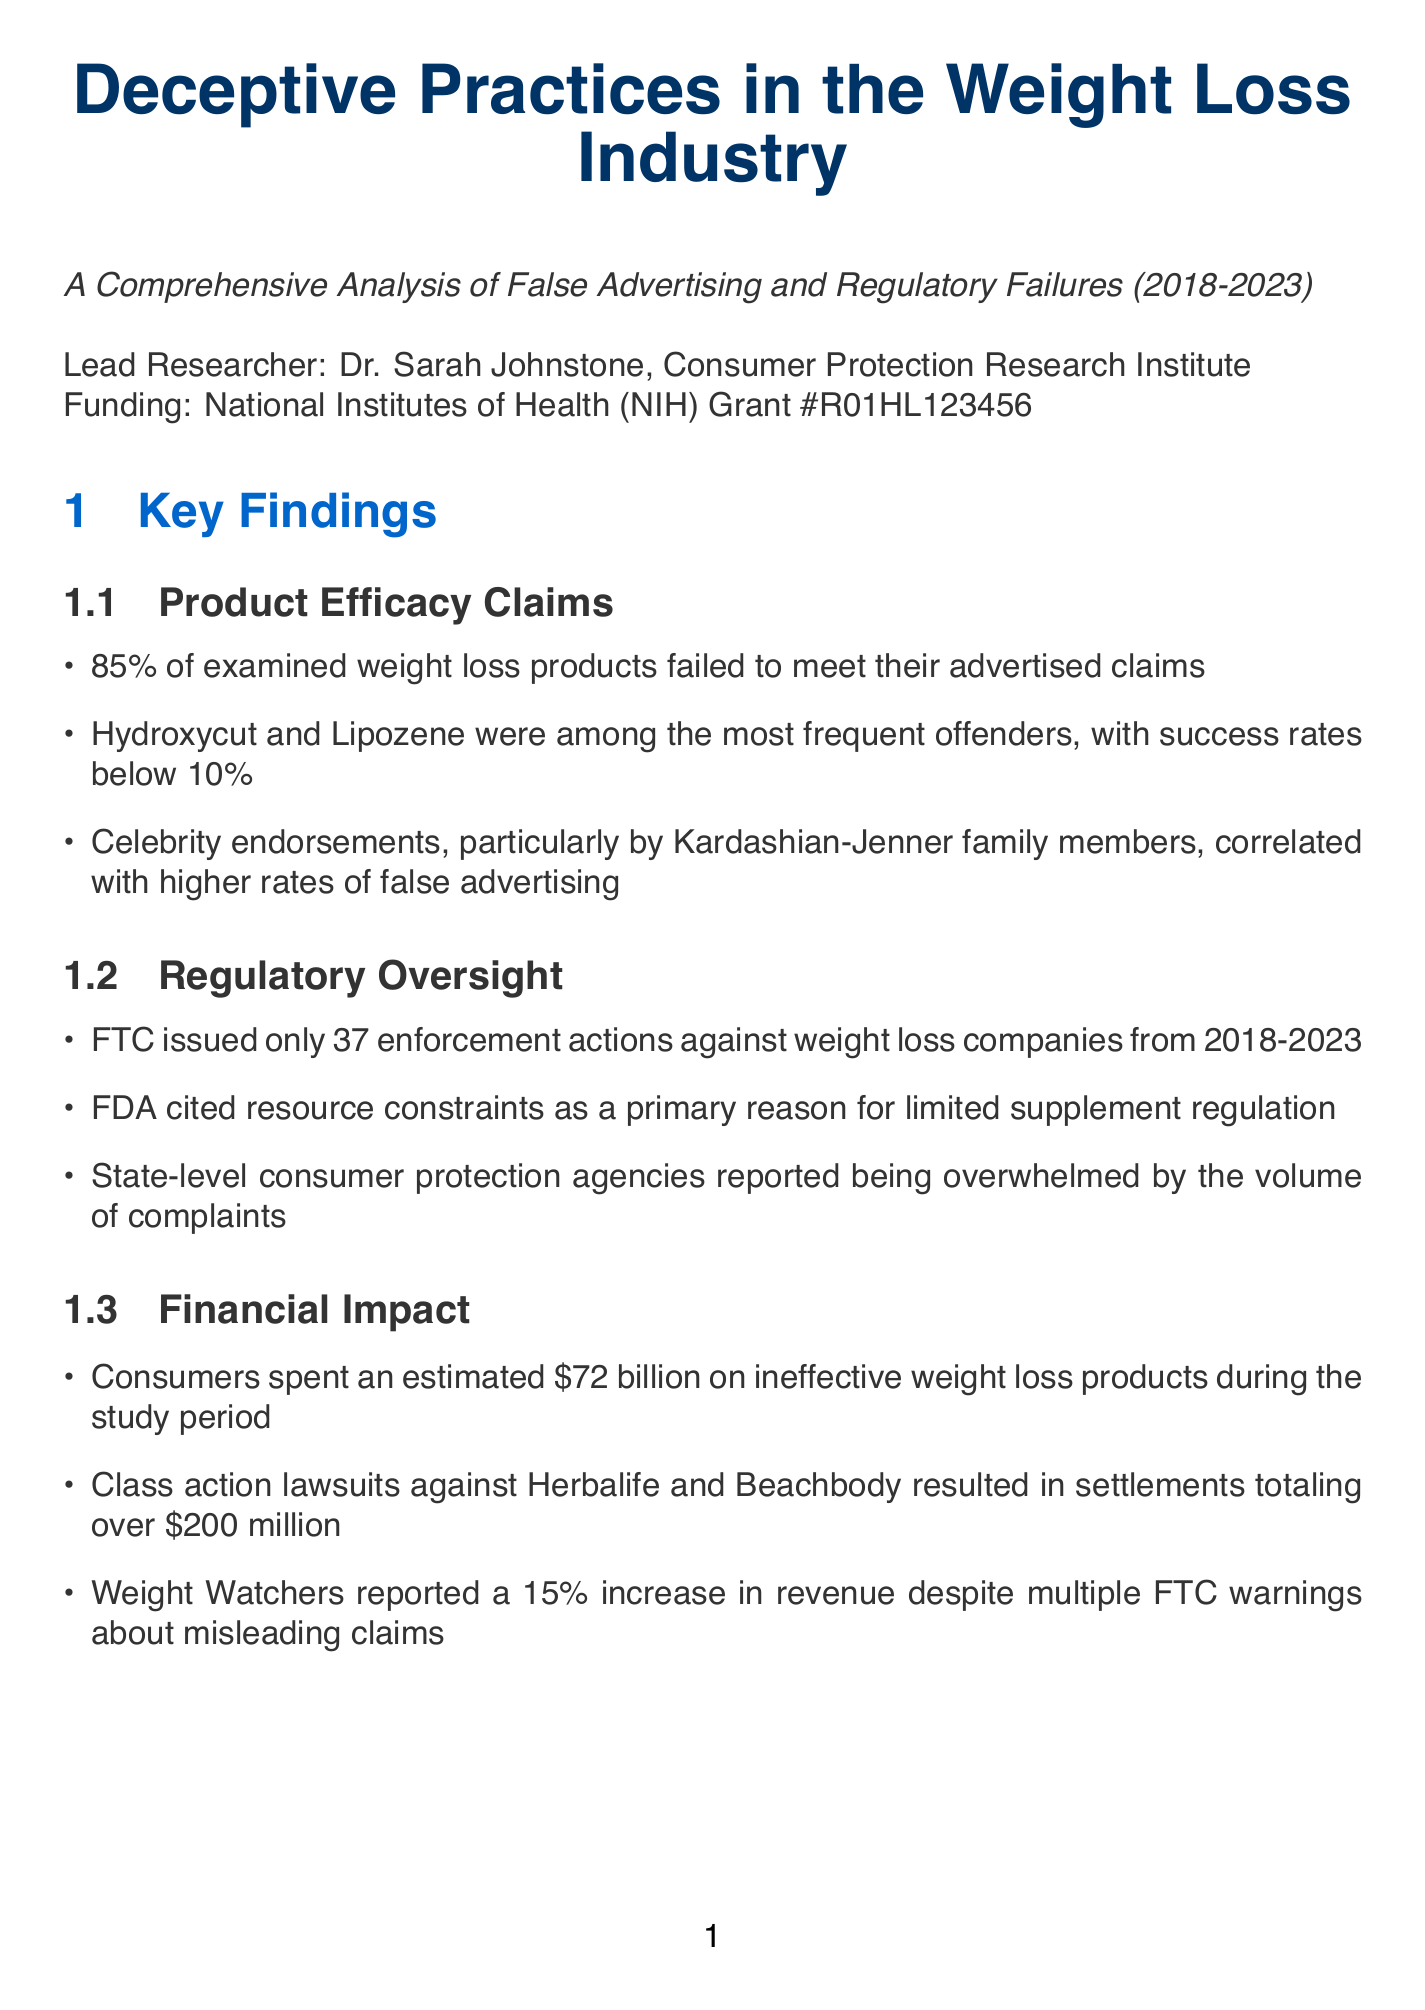What is the title of the study? The title of the study can be found in the overview section of the document.
Answer: Deceptive Practices in the Weight Loss Industry: A Comprehensive Analysis of False Advertising and Regulatory Failures Who is the lead researcher? The lead researcher is specifically mentioned in the study overview section.
Answer: Dr. Sarah Johnstone How many enforcement actions did the FTC issue from 2018-2023? This number is detailed in the regulatory oversight findings of the document.
Answer: 37 What percentage of examined weight loss products failed to meet their advertised claims? This percentage is listed under the key findings related to product efficacy claims.
Answer: 85% What was the FTC fine imposed on Noom, Inc.? The amount of the fine is provided in the case studies section regarding Noom, Inc.
Answer: $9.3 million Which celebrity family was noted for correlating with higher rates of false advertising? This correlation is mentioned in the product efficacy claims subsection.
Answer: Kardashian-Jenner What is one recommendation for improving oversight of weight loss advertising? This recommendation is listed under the recommendations section of the document.
Answer: Increase FTC funding for enforcement actions against deceptive weight loss advertising What was the estimated consumer spending on ineffective weight loss products? This figure is outlined in the financial impact findings of the report.
Answer: $72 billion What regulatory action did Goop face? The regulatory action taken against Goop is described in the case studies section.
Answer: FDA warning letter in 2020, no financial penalties imposed 